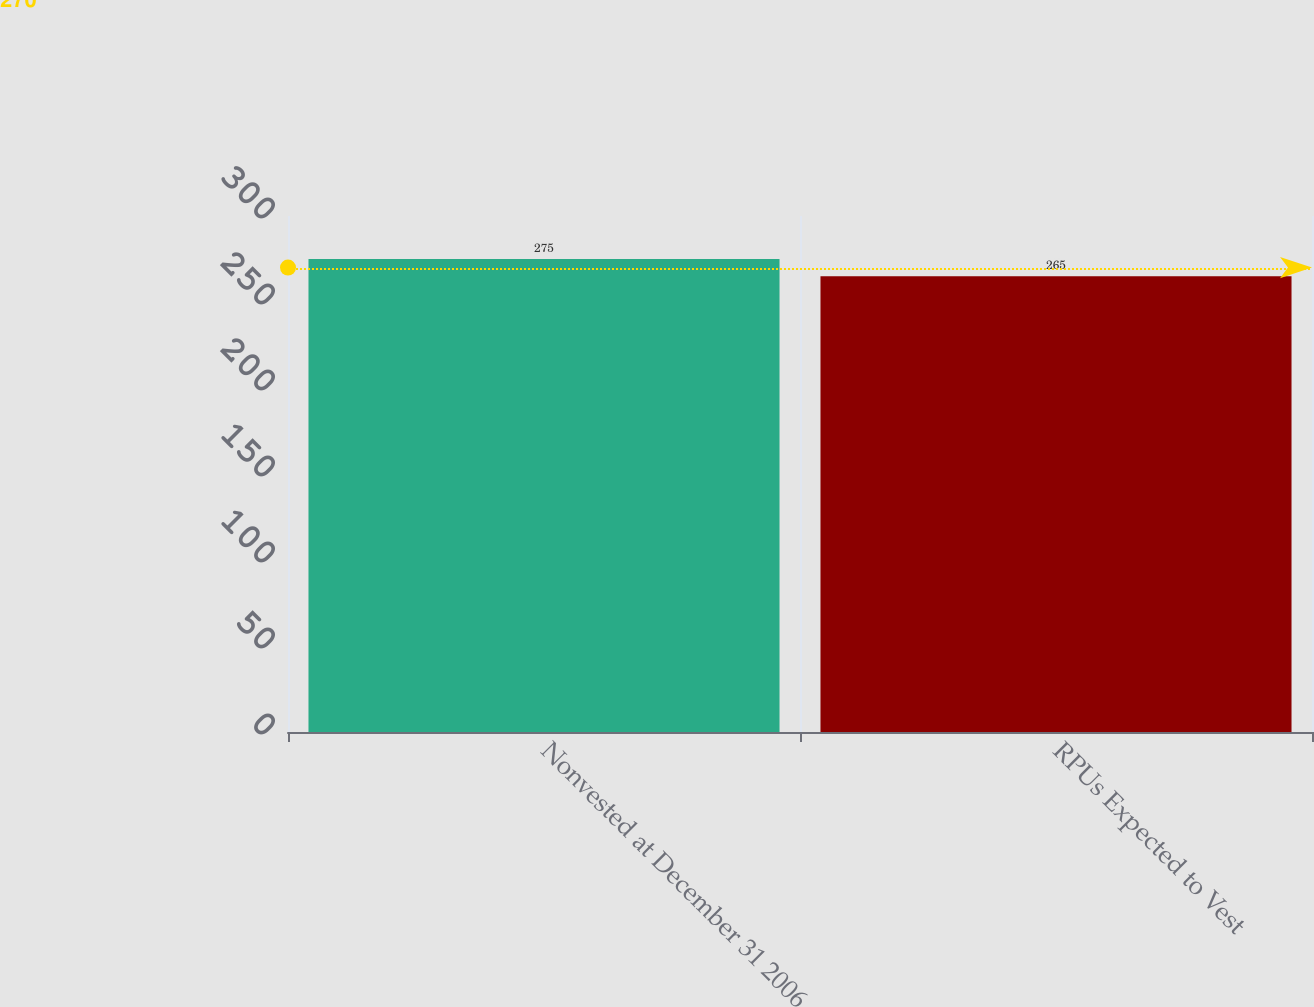Convert chart to OTSL. <chart><loc_0><loc_0><loc_500><loc_500><bar_chart><fcel>Nonvested at December 31 2006<fcel>RPUs Expected to Vest<nl><fcel>275<fcel>265<nl></chart> 